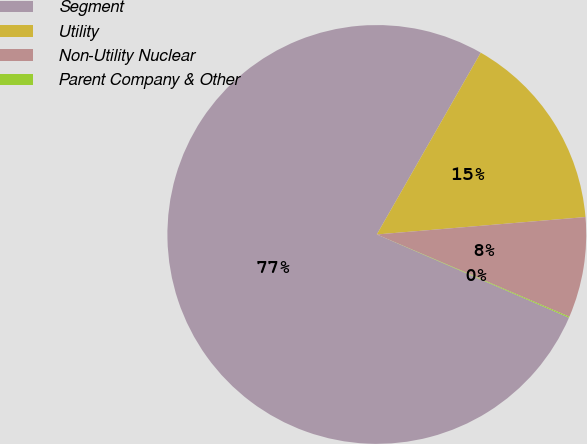<chart> <loc_0><loc_0><loc_500><loc_500><pie_chart><fcel>Segment<fcel>Utility<fcel>Non-Utility Nuclear<fcel>Parent Company & Other<nl><fcel>76.76%<fcel>15.41%<fcel>7.75%<fcel>0.08%<nl></chart> 